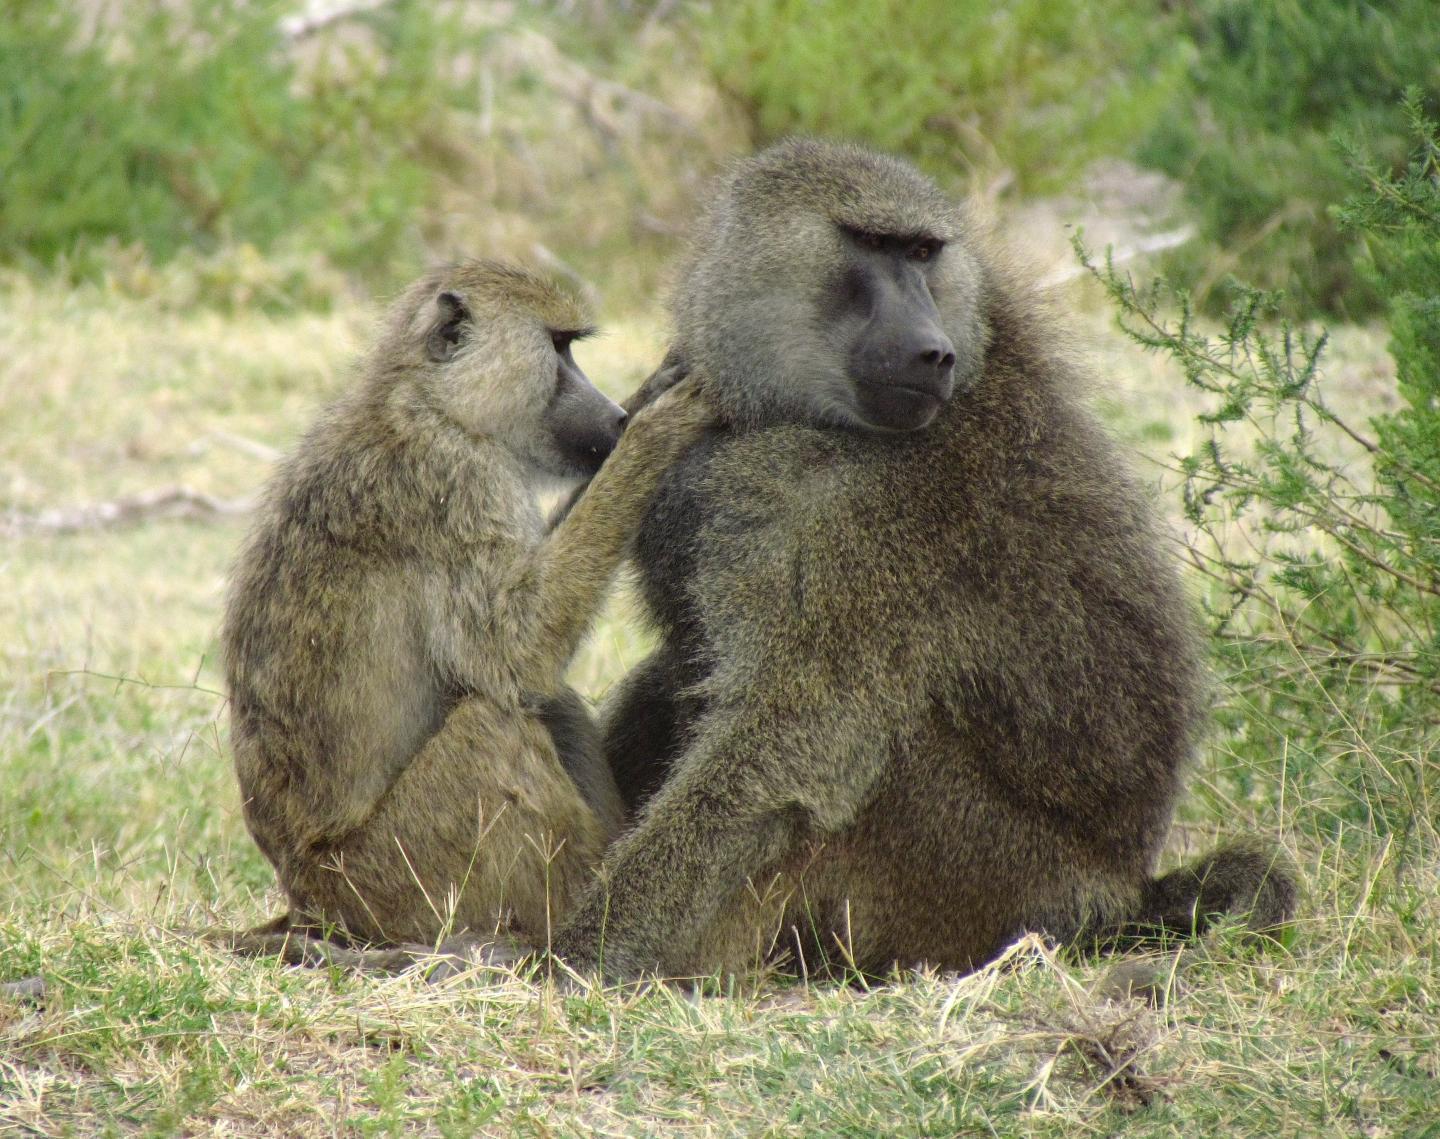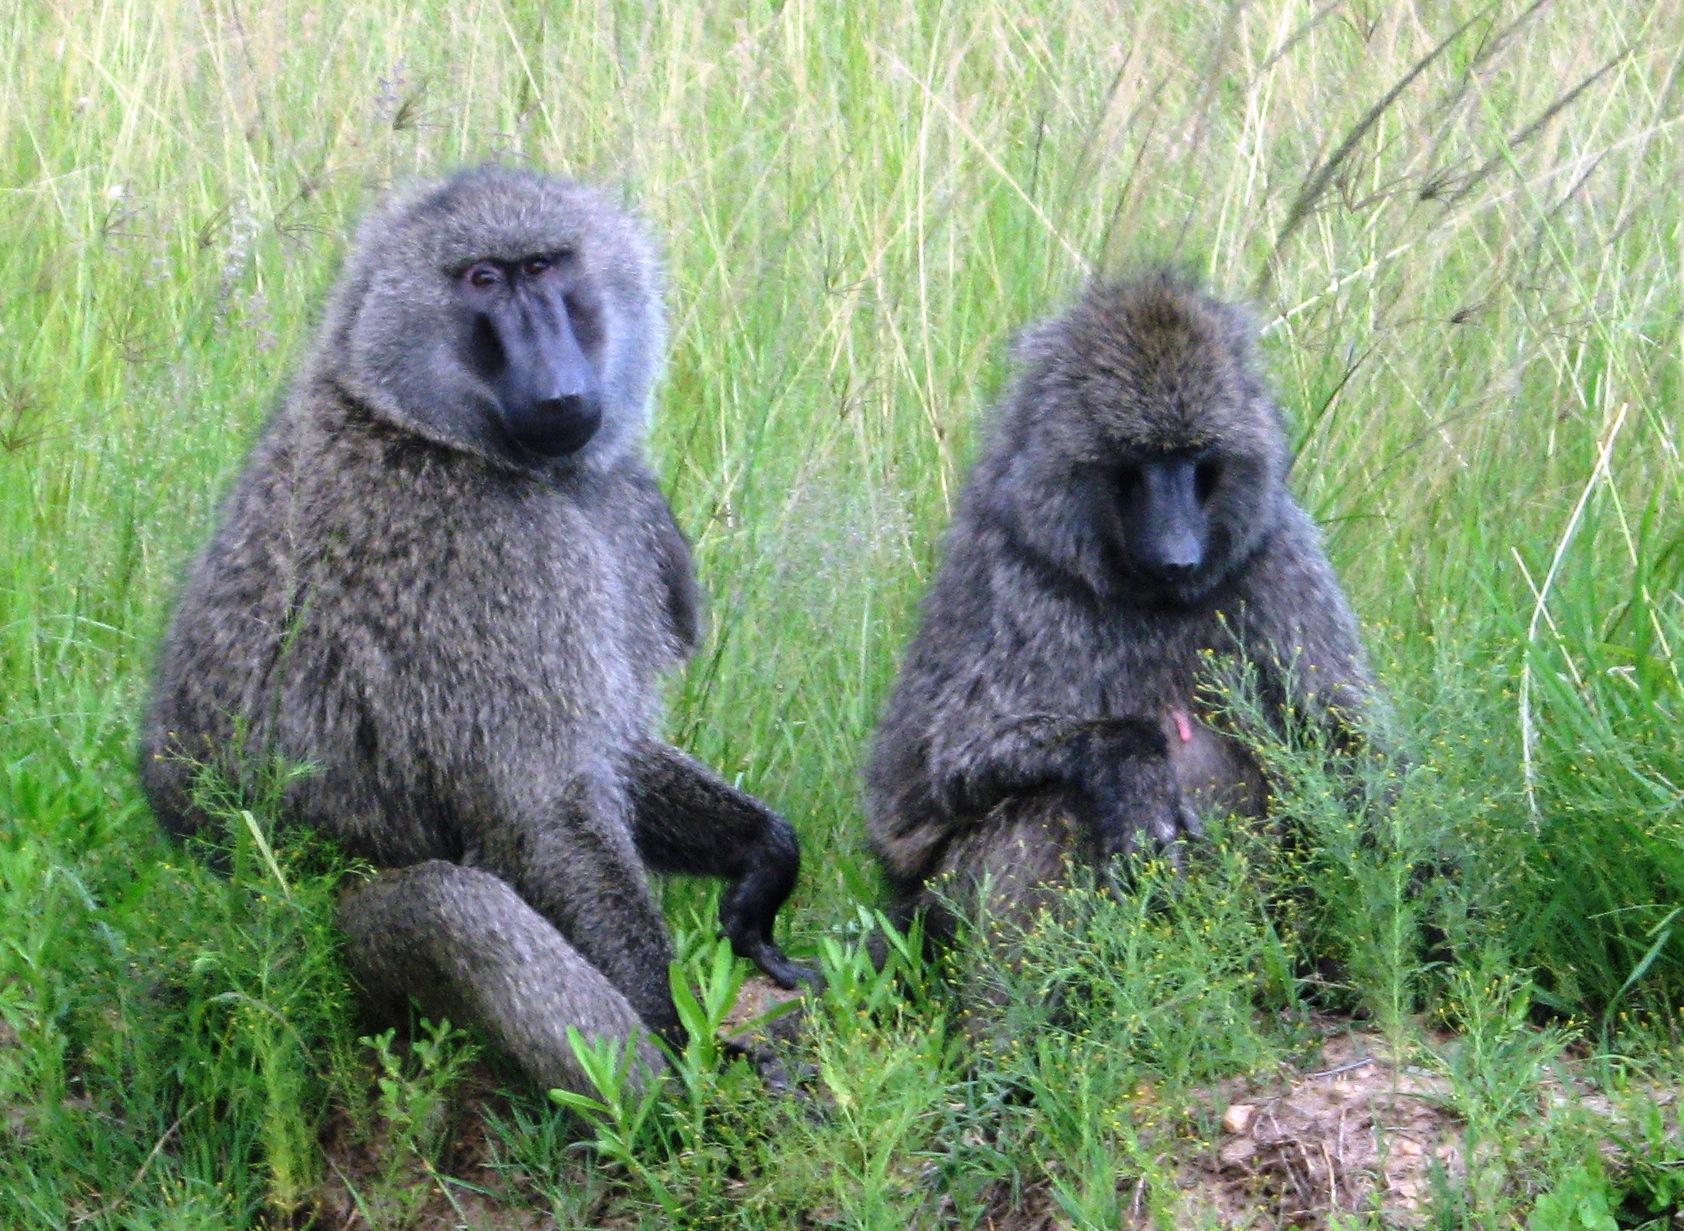The first image is the image on the left, the second image is the image on the right. Considering the images on both sides, is "One monkey is holding onto another monkey from it's back in one of the images." valid? Answer yes or no. No. 